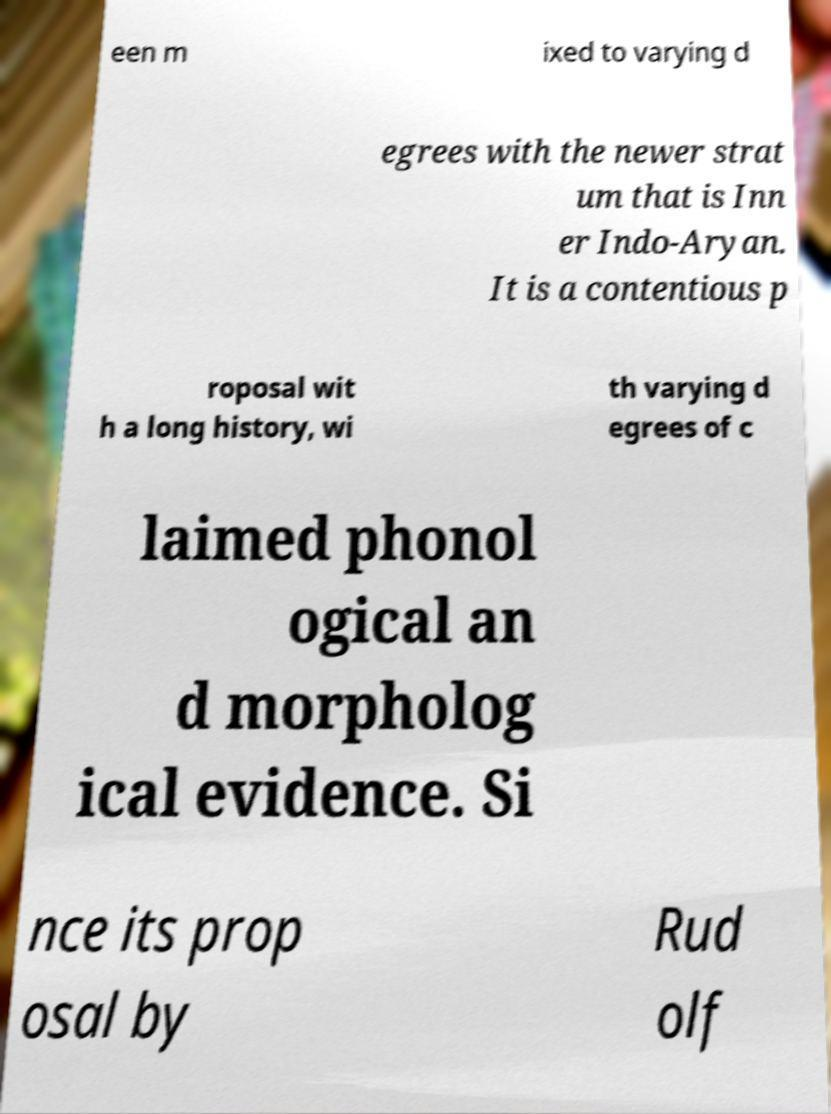Could you assist in decoding the text presented in this image and type it out clearly? een m ixed to varying d egrees with the newer strat um that is Inn er Indo-Aryan. It is a contentious p roposal wit h a long history, wi th varying d egrees of c laimed phonol ogical an d morpholog ical evidence. Si nce its prop osal by Rud olf 